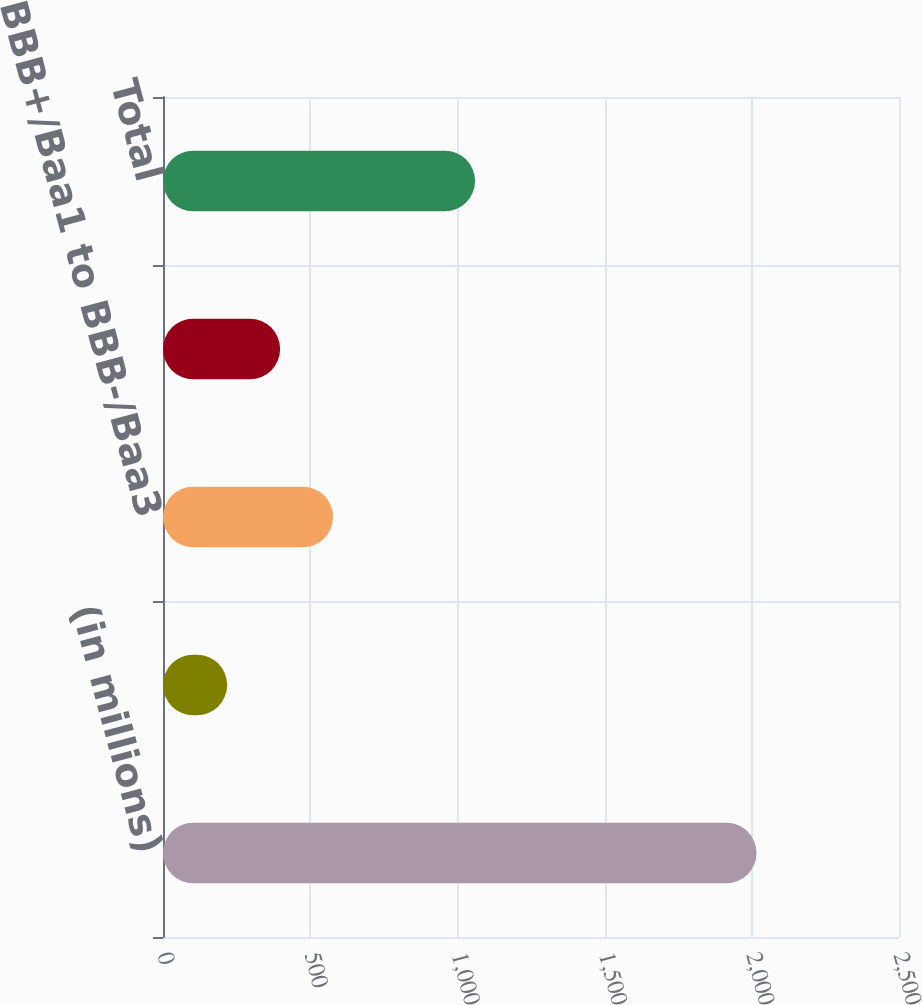Convert chart to OTSL. <chart><loc_0><loc_0><loc_500><loc_500><bar_chart><fcel>(in millions)<fcel>Credit Rating by Standard &<fcel>BBB+/Baa1 to BBB-/Baa3<fcel>BB+/Ba1 and Lower<fcel>Total<nl><fcel>2016<fcel>218<fcel>577.6<fcel>397.8<fcel>1060<nl></chart> 